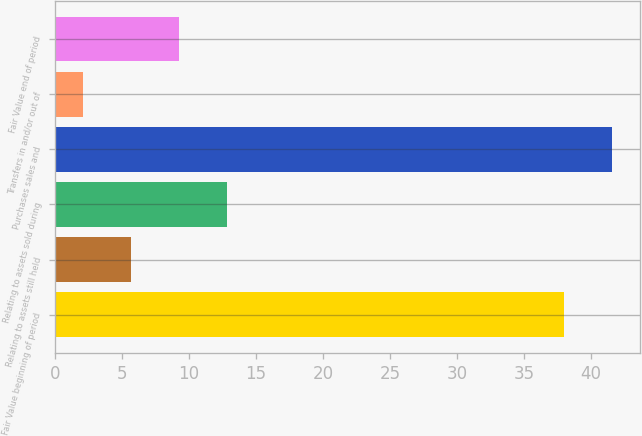Convert chart. <chart><loc_0><loc_0><loc_500><loc_500><bar_chart><fcel>Fair Value beginning of period<fcel>Relating to assets still held<fcel>Relating to assets sold during<fcel>Purchases sales and<fcel>Transfers in and/or out of<fcel>Fair Value end of period<nl><fcel>38<fcel>5.68<fcel>12.86<fcel>41.59<fcel>2.09<fcel>9.27<nl></chart> 